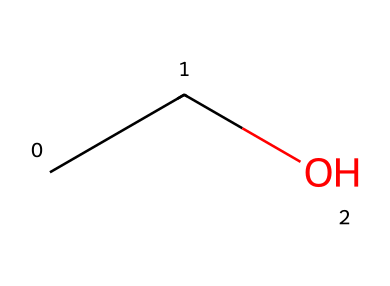What is the molecular formula for this compound? The compound's SMILES representation "CCO" indicates two carbon atoms (C), six hydrogen atoms (H), and one oxygen atom (O), leading to the molecular formula C2H6O.
Answer: C2H6O How many carbon atoms are in ethanol? The SMILES "CCO" shows two carbon (C) symbols, indicating that ethanol contains two carbon atoms.
Answer: 2 What type of functional group is present in this molecule? Ethanol has a hydroxyl (-OH) group, which is characteristic of alcohols, identifiable from the "O" (oxygen) connected to a hydrogen atom (noted in the "CCO" structure).
Answer: hydroxyl Is ethanol a polar or nonpolar solvent? The presence of the hydroxyl group makes ethanol polar due to the electronegative oxygen atom pulling electrons, resulting in a partial charge difference, while the hydrocarbon chain contributes to its polarity.
Answer: polar What is the significance of the hydroxyl group in ethanol? The hydroxyl group (-OH) allows ethanol to engage in hydrogen bonding, enhancing its ability as a solvent in plant extractions, making it more effective in dissolving polar compounds.
Answer: hydrogen bonding What safety consideration should be made regarding ethanol? Ethanol is classified as a flammable liquid, meaning it can ignite easily when exposed to an open flame or spark, necessitating careful handling to prevent fire hazards.
Answer: flammable 